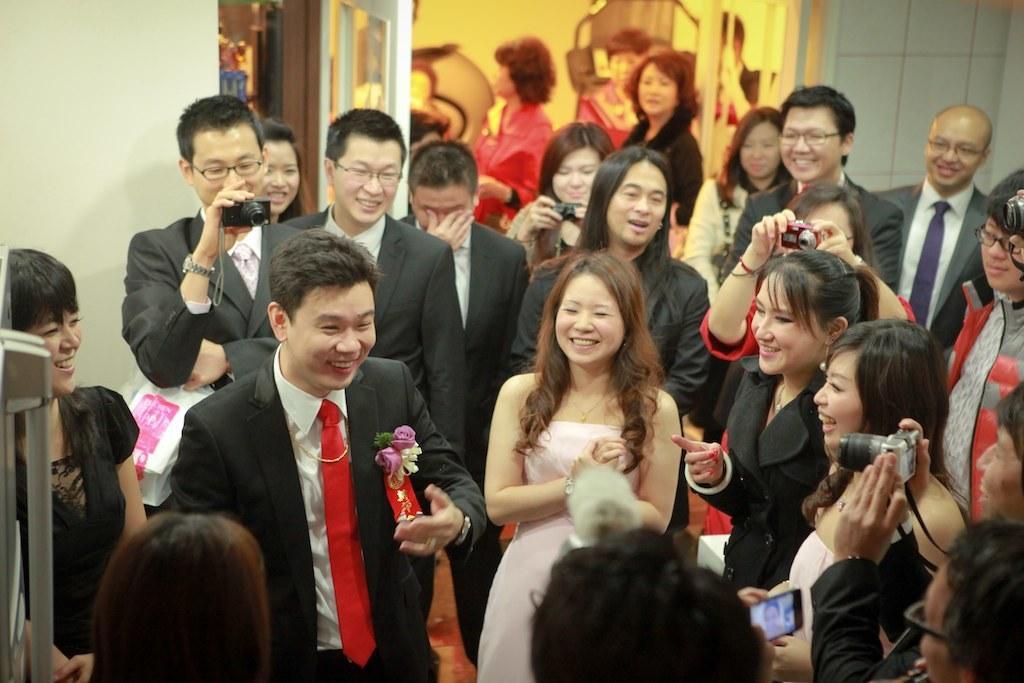Could you give a brief overview of what you see in this image? In the image we can see there are people standing and few people are holding cameras in their hand. The man in front is wearing a red colour tie in his neck. 